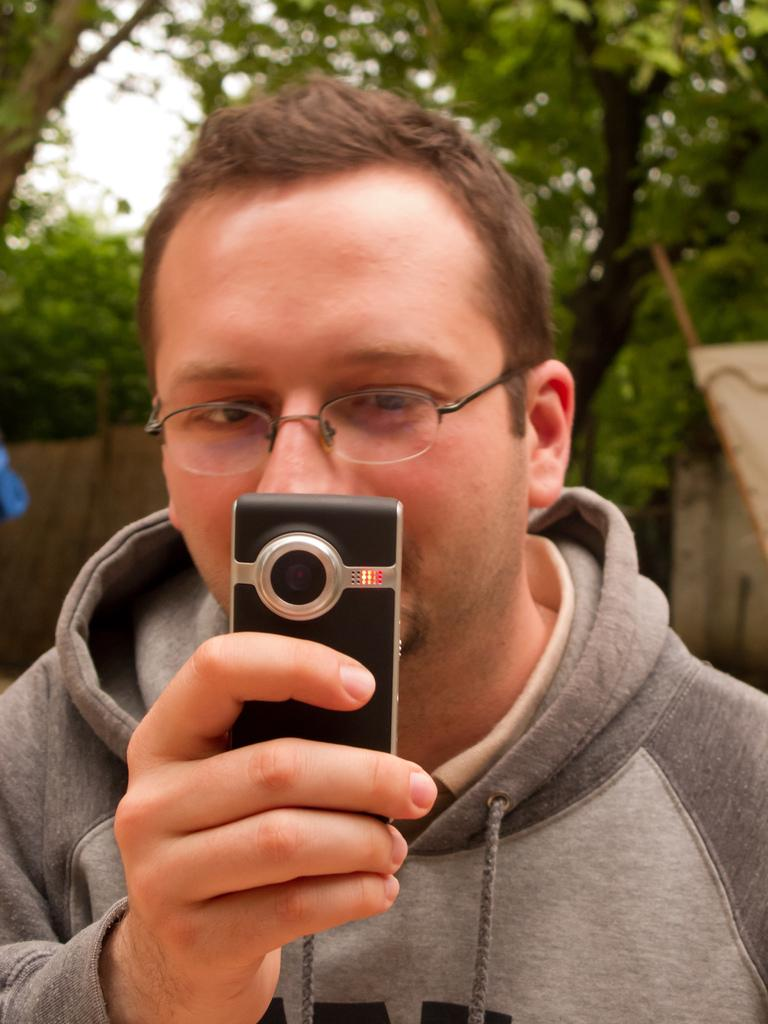Who or what is present in the image? There is a person in the image. What object can be seen with the person? There is a phone in the image. What can be seen in the background of the image? There is a wall and trees in the background of the image. What part of the natural environment is visible in the image? The sky is visible in the image. What type of goose can be seen interacting with the person in the image? There is no goose present in the image; it only features a person and a phone. What attraction is the person visiting in the image? The image does not provide information about any specific attraction or location that the person might be visiting. 